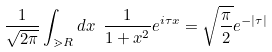Convert formula to latex. <formula><loc_0><loc_0><loc_500><loc_500>\frac { 1 } { \sqrt { 2 \pi } } \int _ { \mathbb { m } { R } } d x \ \frac { 1 } { 1 + x ^ { 2 } } e ^ { i \tau x } = \sqrt { \frac { \pi } { 2 } } e ^ { - | \tau | }</formula> 